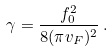<formula> <loc_0><loc_0><loc_500><loc_500>\gamma = \frac { f _ { 0 } ^ { 2 } } { 8 ( \pi v _ { F } ) ^ { 2 } } \, .</formula> 